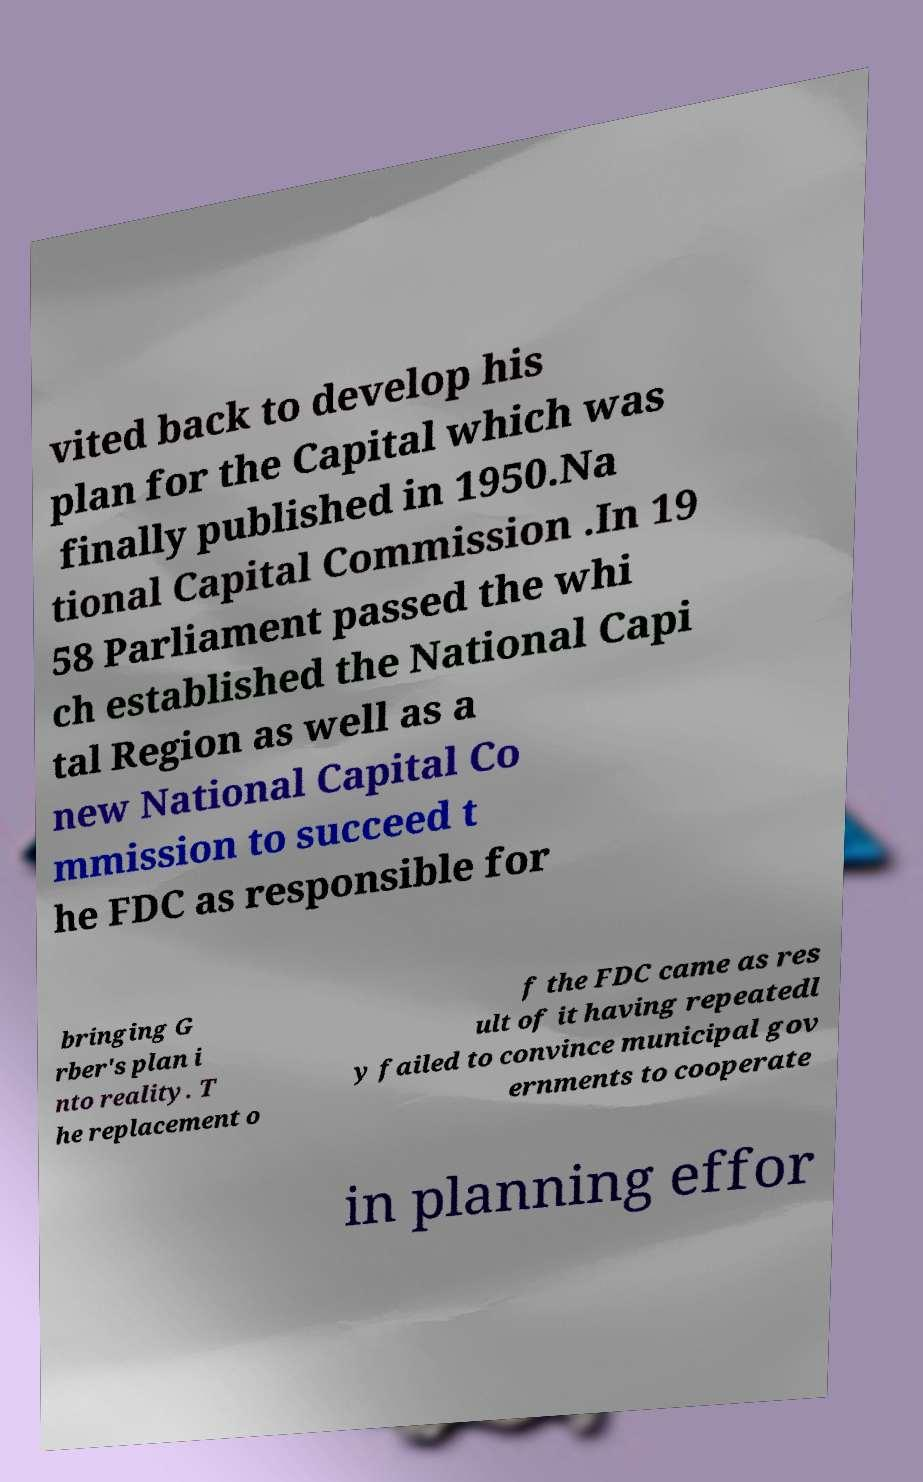Please identify and transcribe the text found in this image. vited back to develop his plan for the Capital which was finally published in 1950.Na tional Capital Commission .In 19 58 Parliament passed the whi ch established the National Capi tal Region as well as a new National Capital Co mmission to succeed t he FDC as responsible for bringing G rber's plan i nto reality. T he replacement o f the FDC came as res ult of it having repeatedl y failed to convince municipal gov ernments to cooperate in planning effor 